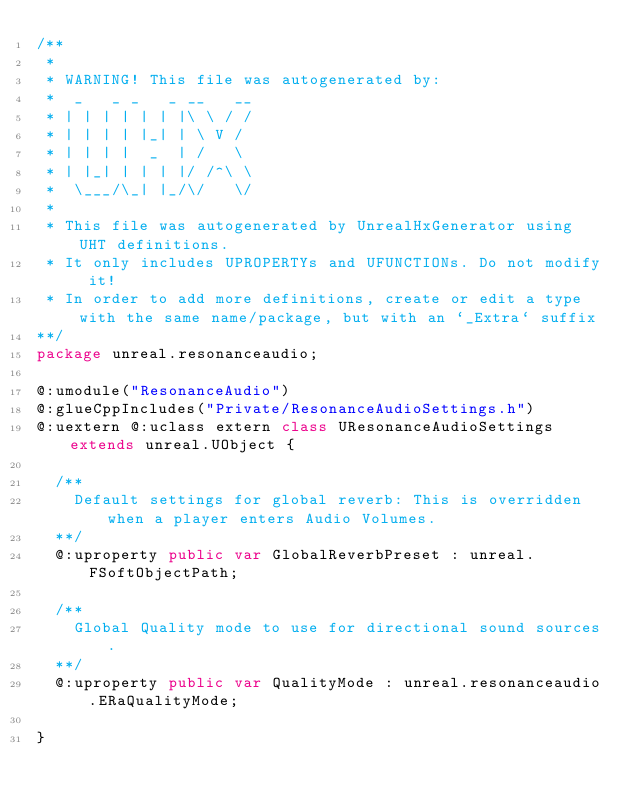Convert code to text. <code><loc_0><loc_0><loc_500><loc_500><_Haxe_>/**
 * 
 * WARNING! This file was autogenerated by: 
 *  _   _ _   _ __   __ 
 * | | | | | | |\ \ / / 
 * | | | | |_| | \ V /  
 * | | | |  _  | /   \  
 * | |_| | | | |/ /^\ \ 
 *  \___/\_| |_/\/   \/ 
 * 
 * This file was autogenerated by UnrealHxGenerator using UHT definitions.
 * It only includes UPROPERTYs and UFUNCTIONs. Do not modify it!
 * In order to add more definitions, create or edit a type with the same name/package, but with an `_Extra` suffix
**/
package unreal.resonanceaudio;

@:umodule("ResonanceAudio")
@:glueCppIncludes("Private/ResonanceAudioSettings.h")
@:uextern @:uclass extern class UResonanceAudioSettings extends unreal.UObject {
  
  /**
    Default settings for global reverb: This is overridden when a player enters Audio Volumes.
  **/
  @:uproperty public var GlobalReverbPreset : unreal.FSoftObjectPath;
  
  /**
    Global Quality mode to use for directional sound sources.
  **/
  @:uproperty public var QualityMode : unreal.resonanceaudio.ERaQualityMode;
  
}
</code> 